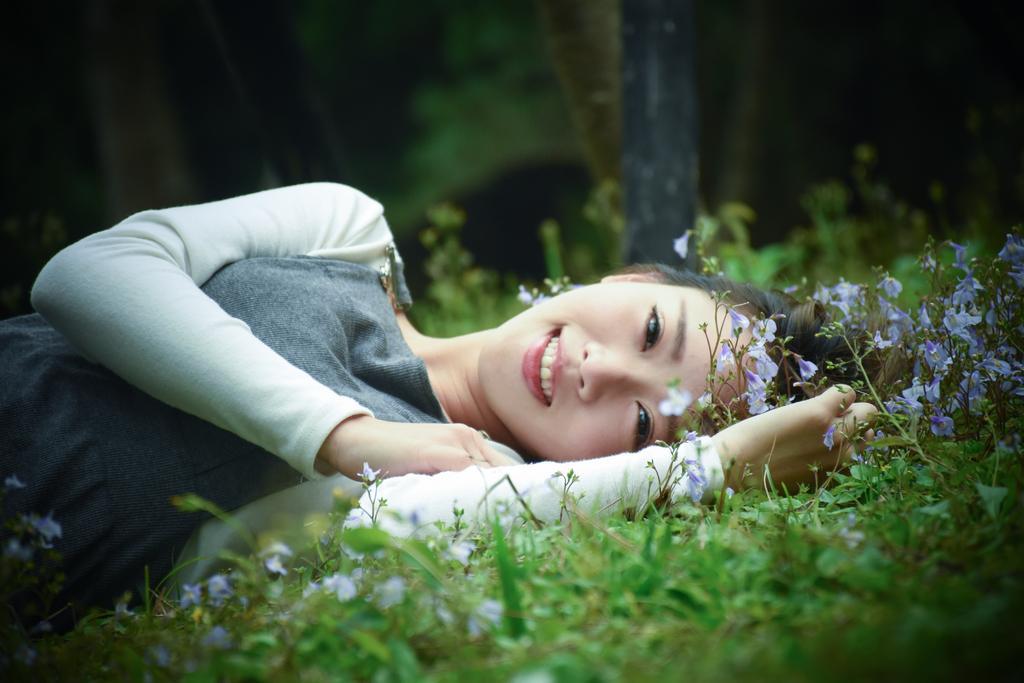How would you summarize this image in a sentence or two? In the picture I can see a woman is lying on the ground and smiling. Here I can see the grass and flowers. The background of the image is blurred. 